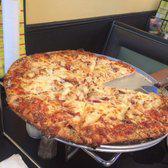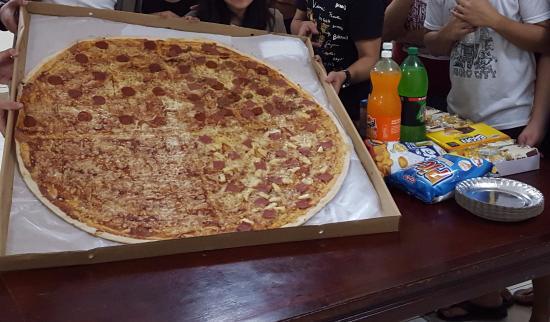The first image is the image on the left, the second image is the image on the right. Examine the images to the left and right. Is the description "The left image features a round pizza on a round metal tray, and the right image features a large round pizza in an open cardboard box with a person on the right of it." accurate? Answer yes or no. Yes. The first image is the image on the left, the second image is the image on the right. Analyze the images presented: Is the assertion "There are two whole pizzas." valid? Answer yes or no. No. 